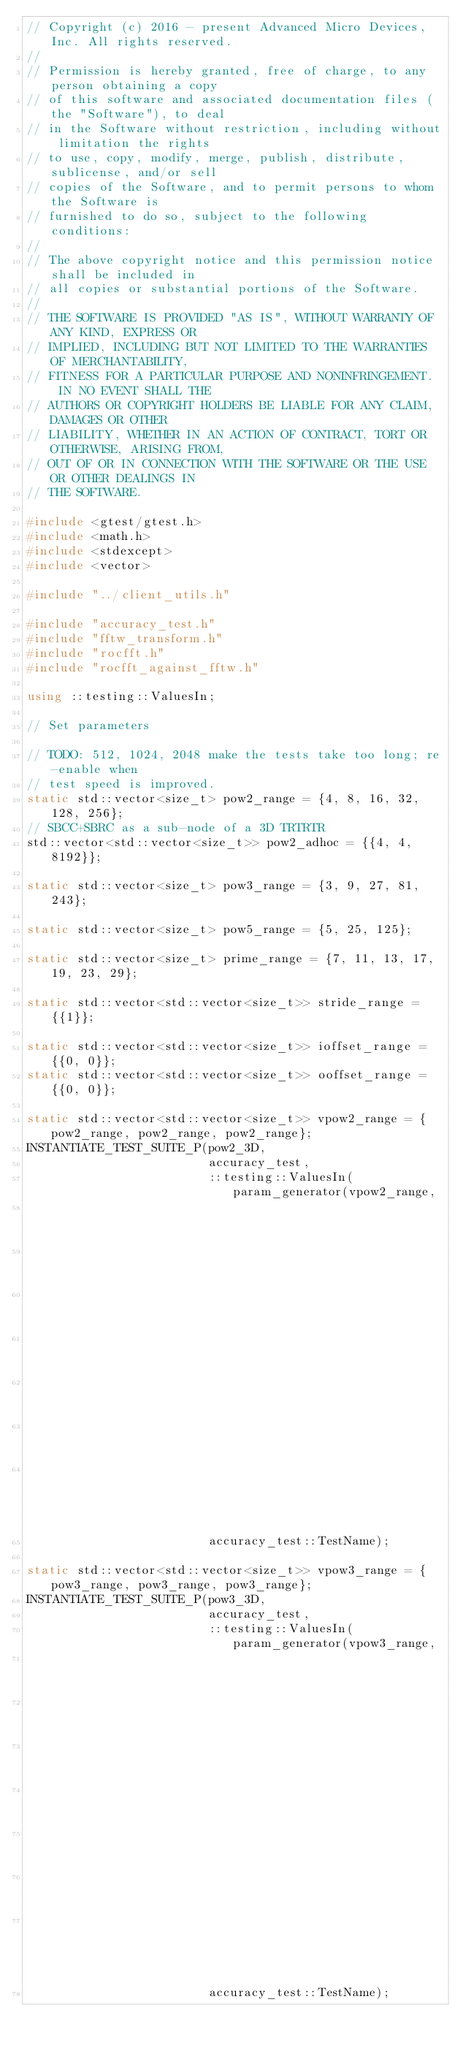Convert code to text. <code><loc_0><loc_0><loc_500><loc_500><_C++_>// Copyright (c) 2016 - present Advanced Micro Devices, Inc. All rights reserved.
//
// Permission is hereby granted, free of charge, to any person obtaining a copy
// of this software and associated documentation files (the "Software"), to deal
// in the Software without restriction, including without limitation the rights
// to use, copy, modify, merge, publish, distribute, sublicense, and/or sell
// copies of the Software, and to permit persons to whom the Software is
// furnished to do so, subject to the following conditions:
//
// The above copyright notice and this permission notice shall be included in
// all copies or substantial portions of the Software.
//
// THE SOFTWARE IS PROVIDED "AS IS", WITHOUT WARRANTY OF ANY KIND, EXPRESS OR
// IMPLIED, INCLUDING BUT NOT LIMITED TO THE WARRANTIES OF MERCHANTABILITY,
// FITNESS FOR A PARTICULAR PURPOSE AND NONINFRINGEMENT.  IN NO EVENT SHALL THE
// AUTHORS OR COPYRIGHT HOLDERS BE LIABLE FOR ANY CLAIM, DAMAGES OR OTHER
// LIABILITY, WHETHER IN AN ACTION OF CONTRACT, TORT OR OTHERWISE, ARISING FROM,
// OUT OF OR IN CONNECTION WITH THE SOFTWARE OR THE USE OR OTHER DEALINGS IN
// THE SOFTWARE.

#include <gtest/gtest.h>
#include <math.h>
#include <stdexcept>
#include <vector>

#include "../client_utils.h"

#include "accuracy_test.h"
#include "fftw_transform.h"
#include "rocfft.h"
#include "rocfft_against_fftw.h"

using ::testing::ValuesIn;

// Set parameters

// TODO: 512, 1024, 2048 make the tests take too long; re-enable when
// test speed is improved.
static std::vector<size_t> pow2_range = {4, 8, 16, 32, 128, 256};
// SBCC+SBRC as a sub-node of a 3D TRTRTR
std::vector<std::vector<size_t>> pow2_adhoc = {{4, 4, 8192}};

static std::vector<size_t> pow3_range = {3, 9, 27, 81, 243};

static std::vector<size_t> pow5_range = {5, 25, 125};

static std::vector<size_t> prime_range = {7, 11, 13, 17, 19, 23, 29};

static std::vector<std::vector<size_t>> stride_range = {{1}};

static std::vector<std::vector<size_t>> ioffset_range = {{0, 0}};
static std::vector<std::vector<size_t>> ooffset_range = {{0, 0}};

static std::vector<std::vector<size_t>> vpow2_range = {pow2_range, pow2_range, pow2_range};
INSTANTIATE_TEST_SUITE_P(pow2_3D,
                         accuracy_test,
                         ::testing::ValuesIn(param_generator(vpow2_range,
                                                             precision_range,
                                                             batch_range,
                                                             stride_range,
                                                             stride_range,
                                                             ioffset_range,
                                                             ooffset_range,
                                                             place_range)),
                         accuracy_test::TestName);

static std::vector<std::vector<size_t>> vpow3_range = {pow3_range, pow3_range, pow3_range};
INSTANTIATE_TEST_SUITE_P(pow3_3D,
                         accuracy_test,
                         ::testing::ValuesIn(param_generator(vpow3_range,
                                                             precision_range,
                                                             batch_range,
                                                             stride_range,
                                                             stride_range,
                                                             ioffset_range,
                                                             ooffset_range,
                                                             place_range)),
                         accuracy_test::TestName);
</code> 